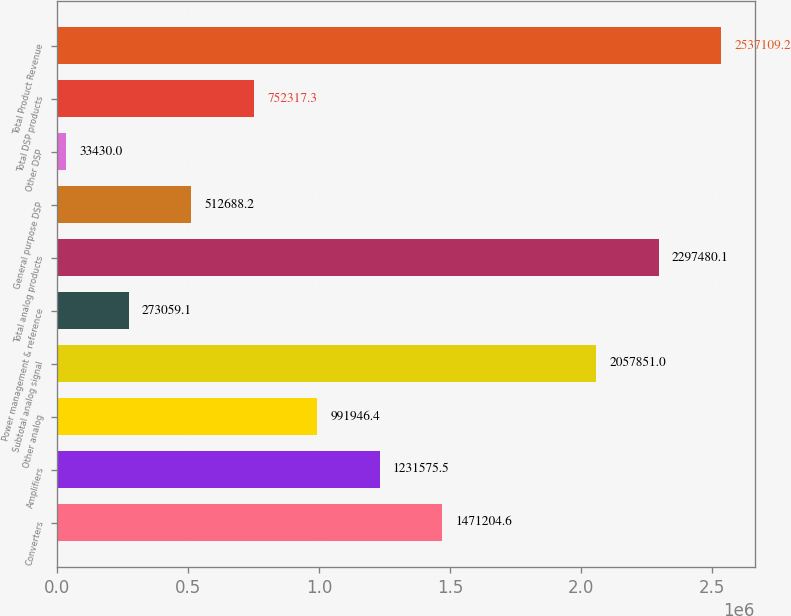Convert chart. <chart><loc_0><loc_0><loc_500><loc_500><bar_chart><fcel>Converters<fcel>Amplifiers<fcel>Other analog<fcel>Subtotal analog signal<fcel>Power management & reference<fcel>Total analog products<fcel>General purpose DSP<fcel>Other DSP<fcel>Total DSP products<fcel>Total Product Revenue<nl><fcel>1.4712e+06<fcel>1.23158e+06<fcel>991946<fcel>2.05785e+06<fcel>273059<fcel>2.29748e+06<fcel>512688<fcel>33430<fcel>752317<fcel>2.53711e+06<nl></chart> 